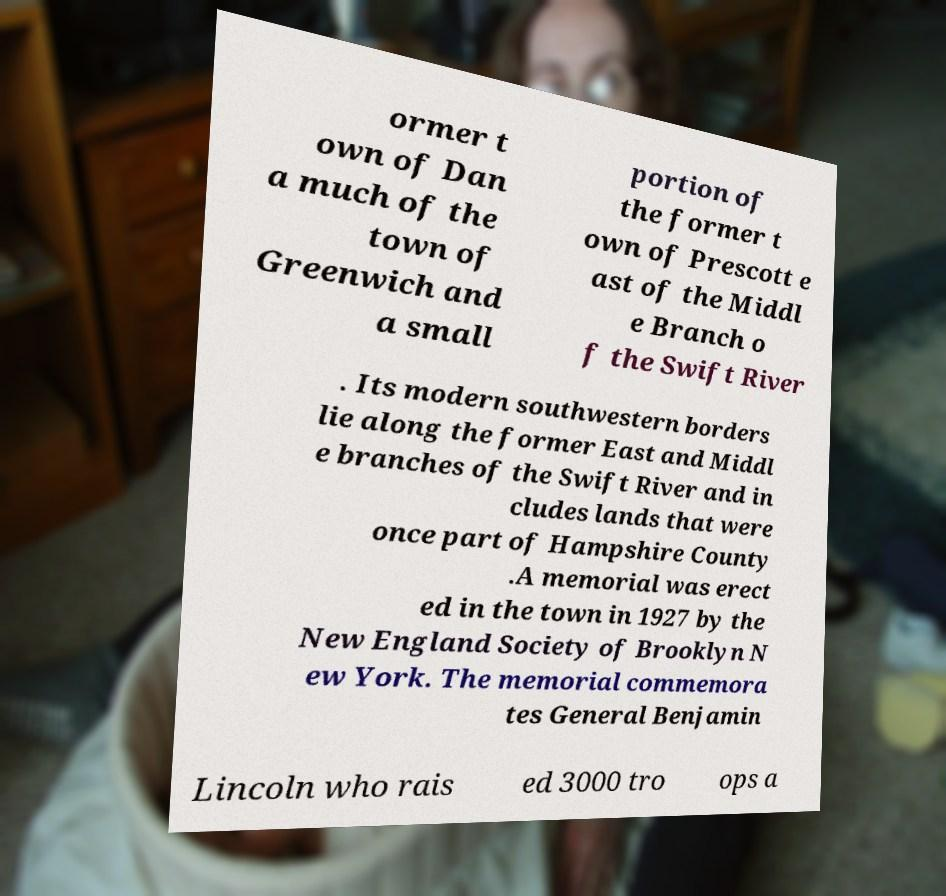There's text embedded in this image that I need extracted. Can you transcribe it verbatim? ormer t own of Dan a much of the town of Greenwich and a small portion of the former t own of Prescott e ast of the Middl e Branch o f the Swift River . Its modern southwestern borders lie along the former East and Middl e branches of the Swift River and in cludes lands that were once part of Hampshire County .A memorial was erect ed in the town in 1927 by the New England Society of Brooklyn N ew York. The memorial commemora tes General Benjamin Lincoln who rais ed 3000 tro ops a 